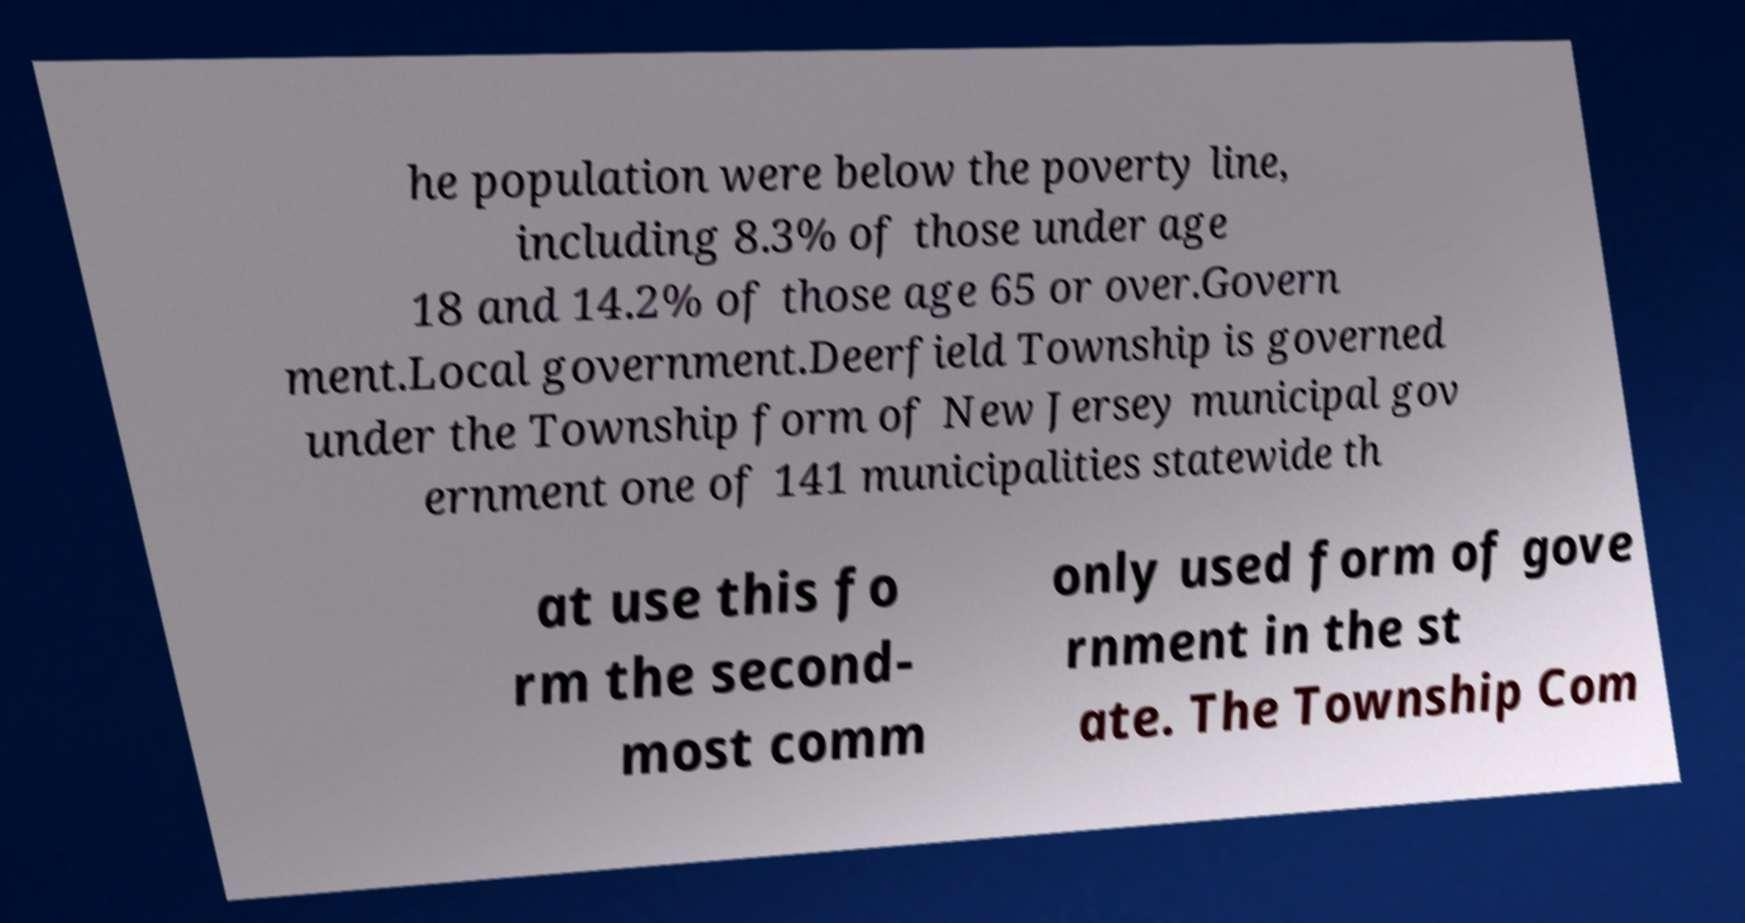What messages or text are displayed in this image? I need them in a readable, typed format. he population were below the poverty line, including 8.3% of those under age 18 and 14.2% of those age 65 or over.Govern ment.Local government.Deerfield Township is governed under the Township form of New Jersey municipal gov ernment one of 141 municipalities statewide th at use this fo rm the second- most comm only used form of gove rnment in the st ate. The Township Com 